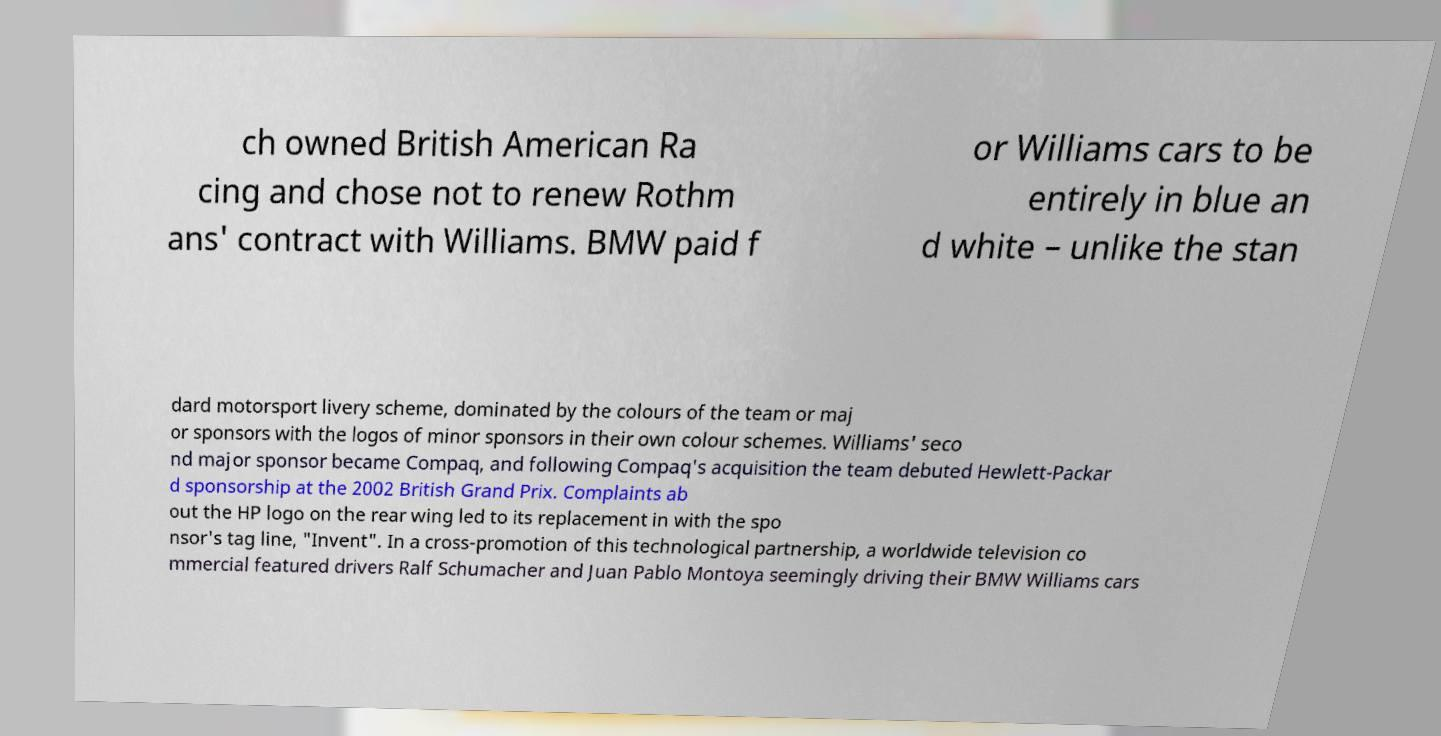What messages or text are displayed in this image? I need them in a readable, typed format. ch owned British American Ra cing and chose not to renew Rothm ans' contract with Williams. BMW paid f or Williams cars to be entirely in blue an d white – unlike the stan dard motorsport livery scheme, dominated by the colours of the team or maj or sponsors with the logos of minor sponsors in their own colour schemes. Williams' seco nd major sponsor became Compaq, and following Compaq's acquisition the team debuted Hewlett-Packar d sponsorship at the 2002 British Grand Prix. Complaints ab out the HP logo on the rear wing led to its replacement in with the spo nsor's tag line, "Invent". In a cross-promotion of this technological partnership, a worldwide television co mmercial featured drivers Ralf Schumacher and Juan Pablo Montoya seemingly driving their BMW Williams cars 